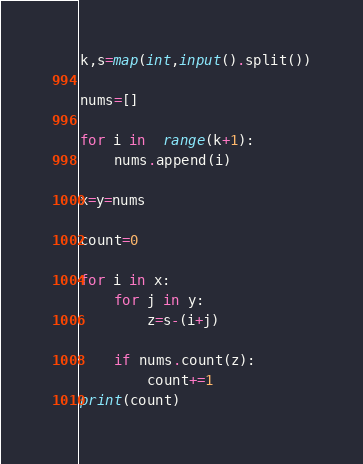<code> <loc_0><loc_0><loc_500><loc_500><_Python_>k,s=map(int,input().split())

nums=[]

for i in  range(k+1):
    nums.append(i)

x=y=nums

count=0

for i in x:
    for j in y:
        z=s-(i+j)

    if nums.count(z):
        count+=1
print(count)
</code> 